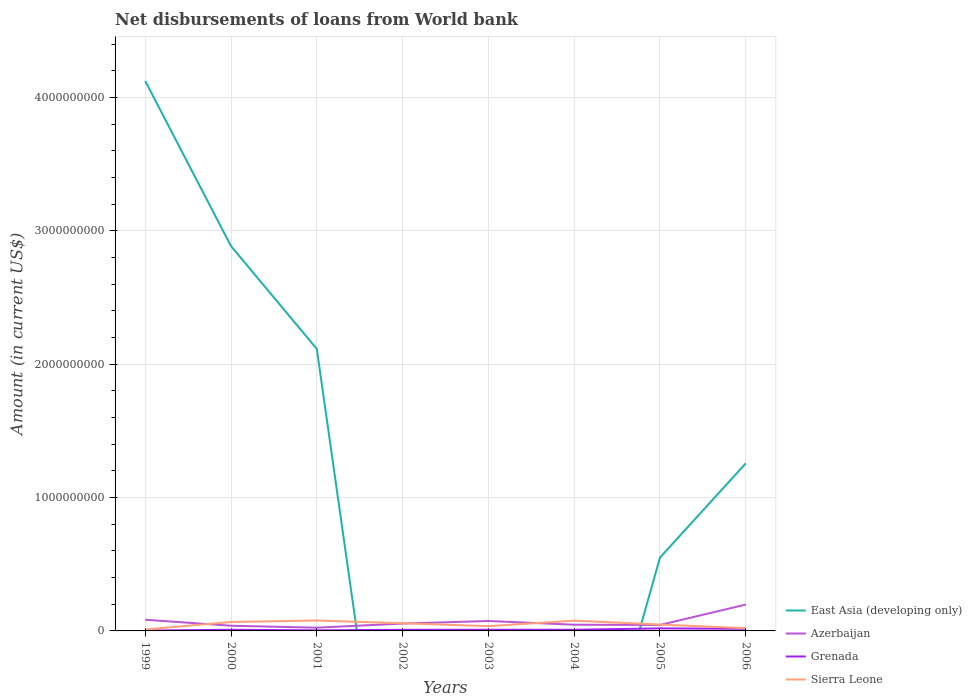How many different coloured lines are there?
Provide a succinct answer. 4. Across all years, what is the maximum amount of loan disbursed from World Bank in Sierra Leone?
Provide a succinct answer. 1.08e+07. What is the total amount of loan disbursed from World Bank in Azerbaijan in the graph?
Provide a succinct answer. 1.05e+07. What is the difference between the highest and the second highest amount of loan disbursed from World Bank in Sierra Leone?
Your response must be concise. 6.74e+07. Is the amount of loan disbursed from World Bank in East Asia (developing only) strictly greater than the amount of loan disbursed from World Bank in Sierra Leone over the years?
Your answer should be very brief. No. Are the values on the major ticks of Y-axis written in scientific E-notation?
Offer a terse response. No. How many legend labels are there?
Your answer should be very brief. 4. How are the legend labels stacked?
Your answer should be compact. Vertical. What is the title of the graph?
Ensure brevity in your answer.  Net disbursements of loans from World bank. What is the label or title of the X-axis?
Your answer should be compact. Years. What is the label or title of the Y-axis?
Offer a very short reply. Amount (in current US$). What is the Amount (in current US$) of East Asia (developing only) in 1999?
Offer a terse response. 4.12e+09. What is the Amount (in current US$) of Azerbaijan in 1999?
Provide a short and direct response. 8.39e+07. What is the Amount (in current US$) in Grenada in 1999?
Offer a terse response. 2.70e+06. What is the Amount (in current US$) in Sierra Leone in 1999?
Ensure brevity in your answer.  1.08e+07. What is the Amount (in current US$) in East Asia (developing only) in 2000?
Provide a short and direct response. 2.89e+09. What is the Amount (in current US$) of Azerbaijan in 2000?
Provide a succinct answer. 3.89e+07. What is the Amount (in current US$) in Grenada in 2000?
Offer a very short reply. 8.52e+06. What is the Amount (in current US$) of Sierra Leone in 2000?
Keep it short and to the point. 6.69e+07. What is the Amount (in current US$) of East Asia (developing only) in 2001?
Make the answer very short. 2.11e+09. What is the Amount (in current US$) in Azerbaijan in 2001?
Offer a very short reply. 2.43e+07. What is the Amount (in current US$) of Grenada in 2001?
Your answer should be compact. 4.25e+06. What is the Amount (in current US$) of Sierra Leone in 2001?
Offer a terse response. 7.82e+07. What is the Amount (in current US$) in Azerbaijan in 2002?
Your answer should be compact. 5.52e+07. What is the Amount (in current US$) in Grenada in 2002?
Offer a very short reply. 8.38e+06. What is the Amount (in current US$) in Sierra Leone in 2002?
Give a very brief answer. 5.74e+07. What is the Amount (in current US$) in Azerbaijan in 2003?
Keep it short and to the point. 7.45e+07. What is the Amount (in current US$) of Grenada in 2003?
Offer a very short reply. 8.82e+06. What is the Amount (in current US$) in Sierra Leone in 2003?
Your answer should be very brief. 3.57e+07. What is the Amount (in current US$) of East Asia (developing only) in 2004?
Give a very brief answer. 0. What is the Amount (in current US$) in Azerbaijan in 2004?
Your response must be concise. 4.63e+07. What is the Amount (in current US$) in Grenada in 2004?
Provide a succinct answer. 8.74e+06. What is the Amount (in current US$) in Sierra Leone in 2004?
Offer a terse response. 7.70e+07. What is the Amount (in current US$) in East Asia (developing only) in 2005?
Your answer should be very brief. 5.50e+08. What is the Amount (in current US$) of Azerbaijan in 2005?
Keep it short and to the point. 4.46e+07. What is the Amount (in current US$) in Grenada in 2005?
Provide a short and direct response. 1.90e+07. What is the Amount (in current US$) in Sierra Leone in 2005?
Ensure brevity in your answer.  4.77e+07. What is the Amount (in current US$) in East Asia (developing only) in 2006?
Your answer should be very brief. 1.26e+09. What is the Amount (in current US$) of Azerbaijan in 2006?
Offer a very short reply. 1.98e+08. What is the Amount (in current US$) of Grenada in 2006?
Ensure brevity in your answer.  1.61e+07. What is the Amount (in current US$) of Sierra Leone in 2006?
Ensure brevity in your answer.  2.05e+07. Across all years, what is the maximum Amount (in current US$) of East Asia (developing only)?
Provide a short and direct response. 4.12e+09. Across all years, what is the maximum Amount (in current US$) of Azerbaijan?
Your answer should be compact. 1.98e+08. Across all years, what is the maximum Amount (in current US$) in Grenada?
Make the answer very short. 1.90e+07. Across all years, what is the maximum Amount (in current US$) of Sierra Leone?
Your answer should be very brief. 7.82e+07. Across all years, what is the minimum Amount (in current US$) in Azerbaijan?
Your answer should be very brief. 2.43e+07. Across all years, what is the minimum Amount (in current US$) of Grenada?
Offer a very short reply. 2.70e+06. Across all years, what is the minimum Amount (in current US$) of Sierra Leone?
Offer a terse response. 1.08e+07. What is the total Amount (in current US$) in East Asia (developing only) in the graph?
Provide a short and direct response. 1.09e+1. What is the total Amount (in current US$) in Azerbaijan in the graph?
Your answer should be very brief. 5.65e+08. What is the total Amount (in current US$) in Grenada in the graph?
Keep it short and to the point. 7.65e+07. What is the total Amount (in current US$) of Sierra Leone in the graph?
Provide a succinct answer. 3.94e+08. What is the difference between the Amount (in current US$) in East Asia (developing only) in 1999 and that in 2000?
Your answer should be very brief. 1.24e+09. What is the difference between the Amount (in current US$) of Azerbaijan in 1999 and that in 2000?
Give a very brief answer. 4.50e+07. What is the difference between the Amount (in current US$) of Grenada in 1999 and that in 2000?
Offer a terse response. -5.82e+06. What is the difference between the Amount (in current US$) of Sierra Leone in 1999 and that in 2000?
Your answer should be very brief. -5.61e+07. What is the difference between the Amount (in current US$) of East Asia (developing only) in 1999 and that in 2001?
Offer a very short reply. 2.01e+09. What is the difference between the Amount (in current US$) in Azerbaijan in 1999 and that in 2001?
Offer a very short reply. 5.96e+07. What is the difference between the Amount (in current US$) of Grenada in 1999 and that in 2001?
Ensure brevity in your answer.  -1.55e+06. What is the difference between the Amount (in current US$) in Sierra Leone in 1999 and that in 2001?
Offer a terse response. -6.74e+07. What is the difference between the Amount (in current US$) in Azerbaijan in 1999 and that in 2002?
Provide a succinct answer. 2.88e+07. What is the difference between the Amount (in current US$) of Grenada in 1999 and that in 2002?
Offer a very short reply. -5.67e+06. What is the difference between the Amount (in current US$) in Sierra Leone in 1999 and that in 2002?
Provide a succinct answer. -4.67e+07. What is the difference between the Amount (in current US$) of Azerbaijan in 1999 and that in 2003?
Offer a very short reply. 9.45e+06. What is the difference between the Amount (in current US$) of Grenada in 1999 and that in 2003?
Offer a very short reply. -6.12e+06. What is the difference between the Amount (in current US$) in Sierra Leone in 1999 and that in 2003?
Provide a short and direct response. -2.50e+07. What is the difference between the Amount (in current US$) of Azerbaijan in 1999 and that in 2004?
Make the answer very short. 3.76e+07. What is the difference between the Amount (in current US$) in Grenada in 1999 and that in 2004?
Offer a very short reply. -6.04e+06. What is the difference between the Amount (in current US$) in Sierra Leone in 1999 and that in 2004?
Ensure brevity in your answer.  -6.63e+07. What is the difference between the Amount (in current US$) of East Asia (developing only) in 1999 and that in 2005?
Ensure brevity in your answer.  3.57e+09. What is the difference between the Amount (in current US$) in Azerbaijan in 1999 and that in 2005?
Offer a terse response. 3.93e+07. What is the difference between the Amount (in current US$) in Grenada in 1999 and that in 2005?
Provide a succinct answer. -1.63e+07. What is the difference between the Amount (in current US$) in Sierra Leone in 1999 and that in 2005?
Provide a short and direct response. -3.70e+07. What is the difference between the Amount (in current US$) in East Asia (developing only) in 1999 and that in 2006?
Your response must be concise. 2.87e+09. What is the difference between the Amount (in current US$) in Azerbaijan in 1999 and that in 2006?
Your response must be concise. -1.14e+08. What is the difference between the Amount (in current US$) of Grenada in 1999 and that in 2006?
Your response must be concise. -1.34e+07. What is the difference between the Amount (in current US$) of Sierra Leone in 1999 and that in 2006?
Offer a terse response. -9.74e+06. What is the difference between the Amount (in current US$) in East Asia (developing only) in 2000 and that in 2001?
Give a very brief answer. 7.71e+08. What is the difference between the Amount (in current US$) in Azerbaijan in 2000 and that in 2001?
Offer a very short reply. 1.46e+07. What is the difference between the Amount (in current US$) of Grenada in 2000 and that in 2001?
Give a very brief answer. 4.27e+06. What is the difference between the Amount (in current US$) in Sierra Leone in 2000 and that in 2001?
Provide a succinct answer. -1.13e+07. What is the difference between the Amount (in current US$) of Azerbaijan in 2000 and that in 2002?
Ensure brevity in your answer.  -1.62e+07. What is the difference between the Amount (in current US$) in Grenada in 2000 and that in 2002?
Give a very brief answer. 1.44e+05. What is the difference between the Amount (in current US$) of Sierra Leone in 2000 and that in 2002?
Provide a short and direct response. 9.44e+06. What is the difference between the Amount (in current US$) of Azerbaijan in 2000 and that in 2003?
Make the answer very short. -3.55e+07. What is the difference between the Amount (in current US$) of Grenada in 2000 and that in 2003?
Your answer should be very brief. -2.98e+05. What is the difference between the Amount (in current US$) in Sierra Leone in 2000 and that in 2003?
Give a very brief answer. 3.12e+07. What is the difference between the Amount (in current US$) in Azerbaijan in 2000 and that in 2004?
Your response must be concise. -7.41e+06. What is the difference between the Amount (in current US$) in Grenada in 2000 and that in 2004?
Give a very brief answer. -2.22e+05. What is the difference between the Amount (in current US$) of Sierra Leone in 2000 and that in 2004?
Keep it short and to the point. -1.02e+07. What is the difference between the Amount (in current US$) in East Asia (developing only) in 2000 and that in 2005?
Provide a short and direct response. 2.34e+09. What is the difference between the Amount (in current US$) of Azerbaijan in 2000 and that in 2005?
Your answer should be compact. -5.71e+06. What is the difference between the Amount (in current US$) in Grenada in 2000 and that in 2005?
Give a very brief answer. -1.05e+07. What is the difference between the Amount (in current US$) in Sierra Leone in 2000 and that in 2005?
Give a very brief answer. 1.91e+07. What is the difference between the Amount (in current US$) of East Asia (developing only) in 2000 and that in 2006?
Keep it short and to the point. 1.63e+09. What is the difference between the Amount (in current US$) of Azerbaijan in 2000 and that in 2006?
Provide a short and direct response. -1.59e+08. What is the difference between the Amount (in current US$) in Grenada in 2000 and that in 2006?
Offer a very short reply. -7.58e+06. What is the difference between the Amount (in current US$) of Sierra Leone in 2000 and that in 2006?
Keep it short and to the point. 4.64e+07. What is the difference between the Amount (in current US$) in Azerbaijan in 2001 and that in 2002?
Make the answer very short. -3.09e+07. What is the difference between the Amount (in current US$) of Grenada in 2001 and that in 2002?
Make the answer very short. -4.12e+06. What is the difference between the Amount (in current US$) in Sierra Leone in 2001 and that in 2002?
Make the answer very short. 2.08e+07. What is the difference between the Amount (in current US$) in Azerbaijan in 2001 and that in 2003?
Make the answer very short. -5.02e+07. What is the difference between the Amount (in current US$) in Grenada in 2001 and that in 2003?
Make the answer very short. -4.57e+06. What is the difference between the Amount (in current US$) in Sierra Leone in 2001 and that in 2003?
Keep it short and to the point. 4.25e+07. What is the difference between the Amount (in current US$) in Azerbaijan in 2001 and that in 2004?
Make the answer very short. -2.20e+07. What is the difference between the Amount (in current US$) of Grenada in 2001 and that in 2004?
Provide a short and direct response. -4.49e+06. What is the difference between the Amount (in current US$) in Sierra Leone in 2001 and that in 2004?
Make the answer very short. 1.15e+06. What is the difference between the Amount (in current US$) of East Asia (developing only) in 2001 and that in 2005?
Your answer should be compact. 1.56e+09. What is the difference between the Amount (in current US$) of Azerbaijan in 2001 and that in 2005?
Offer a terse response. -2.04e+07. What is the difference between the Amount (in current US$) of Grenada in 2001 and that in 2005?
Keep it short and to the point. -1.47e+07. What is the difference between the Amount (in current US$) of Sierra Leone in 2001 and that in 2005?
Provide a succinct answer. 3.05e+07. What is the difference between the Amount (in current US$) of East Asia (developing only) in 2001 and that in 2006?
Your answer should be compact. 8.58e+08. What is the difference between the Amount (in current US$) in Azerbaijan in 2001 and that in 2006?
Keep it short and to the point. -1.73e+08. What is the difference between the Amount (in current US$) of Grenada in 2001 and that in 2006?
Make the answer very short. -1.18e+07. What is the difference between the Amount (in current US$) of Sierra Leone in 2001 and that in 2006?
Ensure brevity in your answer.  5.77e+07. What is the difference between the Amount (in current US$) of Azerbaijan in 2002 and that in 2003?
Make the answer very short. -1.93e+07. What is the difference between the Amount (in current US$) in Grenada in 2002 and that in 2003?
Your answer should be compact. -4.42e+05. What is the difference between the Amount (in current US$) in Sierra Leone in 2002 and that in 2003?
Ensure brevity in your answer.  2.17e+07. What is the difference between the Amount (in current US$) of Azerbaijan in 2002 and that in 2004?
Offer a terse response. 8.82e+06. What is the difference between the Amount (in current US$) in Grenada in 2002 and that in 2004?
Your response must be concise. -3.66e+05. What is the difference between the Amount (in current US$) of Sierra Leone in 2002 and that in 2004?
Your answer should be compact. -1.96e+07. What is the difference between the Amount (in current US$) of Azerbaijan in 2002 and that in 2005?
Ensure brevity in your answer.  1.05e+07. What is the difference between the Amount (in current US$) in Grenada in 2002 and that in 2005?
Keep it short and to the point. -1.06e+07. What is the difference between the Amount (in current US$) of Sierra Leone in 2002 and that in 2005?
Ensure brevity in your answer.  9.70e+06. What is the difference between the Amount (in current US$) in Azerbaijan in 2002 and that in 2006?
Keep it short and to the point. -1.42e+08. What is the difference between the Amount (in current US$) in Grenada in 2002 and that in 2006?
Ensure brevity in your answer.  -7.72e+06. What is the difference between the Amount (in current US$) in Sierra Leone in 2002 and that in 2006?
Provide a short and direct response. 3.69e+07. What is the difference between the Amount (in current US$) in Azerbaijan in 2003 and that in 2004?
Your response must be concise. 2.81e+07. What is the difference between the Amount (in current US$) of Grenada in 2003 and that in 2004?
Provide a short and direct response. 7.60e+04. What is the difference between the Amount (in current US$) in Sierra Leone in 2003 and that in 2004?
Keep it short and to the point. -4.13e+07. What is the difference between the Amount (in current US$) of Azerbaijan in 2003 and that in 2005?
Make the answer very short. 2.98e+07. What is the difference between the Amount (in current US$) in Grenada in 2003 and that in 2005?
Your answer should be compact. -1.02e+07. What is the difference between the Amount (in current US$) of Sierra Leone in 2003 and that in 2005?
Provide a short and direct response. -1.20e+07. What is the difference between the Amount (in current US$) in Azerbaijan in 2003 and that in 2006?
Offer a very short reply. -1.23e+08. What is the difference between the Amount (in current US$) in Grenada in 2003 and that in 2006?
Give a very brief answer. -7.28e+06. What is the difference between the Amount (in current US$) of Sierra Leone in 2003 and that in 2006?
Your response must be concise. 1.52e+07. What is the difference between the Amount (in current US$) in Azerbaijan in 2004 and that in 2005?
Your response must be concise. 1.70e+06. What is the difference between the Amount (in current US$) in Grenada in 2004 and that in 2005?
Make the answer very short. -1.02e+07. What is the difference between the Amount (in current US$) of Sierra Leone in 2004 and that in 2005?
Ensure brevity in your answer.  2.93e+07. What is the difference between the Amount (in current US$) in Azerbaijan in 2004 and that in 2006?
Offer a very short reply. -1.51e+08. What is the difference between the Amount (in current US$) in Grenada in 2004 and that in 2006?
Provide a short and direct response. -7.36e+06. What is the difference between the Amount (in current US$) of Sierra Leone in 2004 and that in 2006?
Your answer should be very brief. 5.65e+07. What is the difference between the Amount (in current US$) of East Asia (developing only) in 2005 and that in 2006?
Your answer should be compact. -7.06e+08. What is the difference between the Amount (in current US$) of Azerbaijan in 2005 and that in 2006?
Ensure brevity in your answer.  -1.53e+08. What is the difference between the Amount (in current US$) of Grenada in 2005 and that in 2006?
Keep it short and to the point. 2.88e+06. What is the difference between the Amount (in current US$) in Sierra Leone in 2005 and that in 2006?
Give a very brief answer. 2.72e+07. What is the difference between the Amount (in current US$) in East Asia (developing only) in 1999 and the Amount (in current US$) in Azerbaijan in 2000?
Offer a very short reply. 4.08e+09. What is the difference between the Amount (in current US$) in East Asia (developing only) in 1999 and the Amount (in current US$) in Grenada in 2000?
Offer a very short reply. 4.11e+09. What is the difference between the Amount (in current US$) in East Asia (developing only) in 1999 and the Amount (in current US$) in Sierra Leone in 2000?
Provide a short and direct response. 4.06e+09. What is the difference between the Amount (in current US$) of Azerbaijan in 1999 and the Amount (in current US$) of Grenada in 2000?
Offer a terse response. 7.54e+07. What is the difference between the Amount (in current US$) in Azerbaijan in 1999 and the Amount (in current US$) in Sierra Leone in 2000?
Offer a terse response. 1.71e+07. What is the difference between the Amount (in current US$) of Grenada in 1999 and the Amount (in current US$) of Sierra Leone in 2000?
Provide a succinct answer. -6.42e+07. What is the difference between the Amount (in current US$) of East Asia (developing only) in 1999 and the Amount (in current US$) of Azerbaijan in 2001?
Give a very brief answer. 4.10e+09. What is the difference between the Amount (in current US$) of East Asia (developing only) in 1999 and the Amount (in current US$) of Grenada in 2001?
Ensure brevity in your answer.  4.12e+09. What is the difference between the Amount (in current US$) of East Asia (developing only) in 1999 and the Amount (in current US$) of Sierra Leone in 2001?
Offer a terse response. 4.05e+09. What is the difference between the Amount (in current US$) in Azerbaijan in 1999 and the Amount (in current US$) in Grenada in 2001?
Offer a terse response. 7.97e+07. What is the difference between the Amount (in current US$) in Azerbaijan in 1999 and the Amount (in current US$) in Sierra Leone in 2001?
Offer a very short reply. 5.74e+06. What is the difference between the Amount (in current US$) of Grenada in 1999 and the Amount (in current US$) of Sierra Leone in 2001?
Your answer should be very brief. -7.55e+07. What is the difference between the Amount (in current US$) in East Asia (developing only) in 1999 and the Amount (in current US$) in Azerbaijan in 2002?
Offer a very short reply. 4.07e+09. What is the difference between the Amount (in current US$) in East Asia (developing only) in 1999 and the Amount (in current US$) in Grenada in 2002?
Keep it short and to the point. 4.11e+09. What is the difference between the Amount (in current US$) in East Asia (developing only) in 1999 and the Amount (in current US$) in Sierra Leone in 2002?
Provide a short and direct response. 4.07e+09. What is the difference between the Amount (in current US$) of Azerbaijan in 1999 and the Amount (in current US$) of Grenada in 2002?
Provide a short and direct response. 7.56e+07. What is the difference between the Amount (in current US$) of Azerbaijan in 1999 and the Amount (in current US$) of Sierra Leone in 2002?
Your response must be concise. 2.65e+07. What is the difference between the Amount (in current US$) of Grenada in 1999 and the Amount (in current US$) of Sierra Leone in 2002?
Ensure brevity in your answer.  -5.47e+07. What is the difference between the Amount (in current US$) in East Asia (developing only) in 1999 and the Amount (in current US$) in Azerbaijan in 2003?
Give a very brief answer. 4.05e+09. What is the difference between the Amount (in current US$) in East Asia (developing only) in 1999 and the Amount (in current US$) in Grenada in 2003?
Offer a terse response. 4.11e+09. What is the difference between the Amount (in current US$) in East Asia (developing only) in 1999 and the Amount (in current US$) in Sierra Leone in 2003?
Ensure brevity in your answer.  4.09e+09. What is the difference between the Amount (in current US$) in Azerbaijan in 1999 and the Amount (in current US$) in Grenada in 2003?
Provide a short and direct response. 7.51e+07. What is the difference between the Amount (in current US$) of Azerbaijan in 1999 and the Amount (in current US$) of Sierra Leone in 2003?
Your answer should be very brief. 4.82e+07. What is the difference between the Amount (in current US$) of Grenada in 1999 and the Amount (in current US$) of Sierra Leone in 2003?
Give a very brief answer. -3.30e+07. What is the difference between the Amount (in current US$) of East Asia (developing only) in 1999 and the Amount (in current US$) of Azerbaijan in 2004?
Offer a terse response. 4.08e+09. What is the difference between the Amount (in current US$) of East Asia (developing only) in 1999 and the Amount (in current US$) of Grenada in 2004?
Give a very brief answer. 4.11e+09. What is the difference between the Amount (in current US$) in East Asia (developing only) in 1999 and the Amount (in current US$) in Sierra Leone in 2004?
Ensure brevity in your answer.  4.05e+09. What is the difference between the Amount (in current US$) of Azerbaijan in 1999 and the Amount (in current US$) of Grenada in 2004?
Your response must be concise. 7.52e+07. What is the difference between the Amount (in current US$) in Azerbaijan in 1999 and the Amount (in current US$) in Sierra Leone in 2004?
Keep it short and to the point. 6.89e+06. What is the difference between the Amount (in current US$) in Grenada in 1999 and the Amount (in current US$) in Sierra Leone in 2004?
Ensure brevity in your answer.  -7.43e+07. What is the difference between the Amount (in current US$) of East Asia (developing only) in 1999 and the Amount (in current US$) of Azerbaijan in 2005?
Offer a terse response. 4.08e+09. What is the difference between the Amount (in current US$) in East Asia (developing only) in 1999 and the Amount (in current US$) in Grenada in 2005?
Keep it short and to the point. 4.10e+09. What is the difference between the Amount (in current US$) in East Asia (developing only) in 1999 and the Amount (in current US$) in Sierra Leone in 2005?
Make the answer very short. 4.08e+09. What is the difference between the Amount (in current US$) of Azerbaijan in 1999 and the Amount (in current US$) of Grenada in 2005?
Keep it short and to the point. 6.50e+07. What is the difference between the Amount (in current US$) in Azerbaijan in 1999 and the Amount (in current US$) in Sierra Leone in 2005?
Provide a succinct answer. 3.62e+07. What is the difference between the Amount (in current US$) of Grenada in 1999 and the Amount (in current US$) of Sierra Leone in 2005?
Your answer should be very brief. -4.50e+07. What is the difference between the Amount (in current US$) in East Asia (developing only) in 1999 and the Amount (in current US$) in Azerbaijan in 2006?
Keep it short and to the point. 3.93e+09. What is the difference between the Amount (in current US$) of East Asia (developing only) in 1999 and the Amount (in current US$) of Grenada in 2006?
Offer a very short reply. 4.11e+09. What is the difference between the Amount (in current US$) of East Asia (developing only) in 1999 and the Amount (in current US$) of Sierra Leone in 2006?
Your answer should be compact. 4.10e+09. What is the difference between the Amount (in current US$) of Azerbaijan in 1999 and the Amount (in current US$) of Grenada in 2006?
Offer a terse response. 6.78e+07. What is the difference between the Amount (in current US$) in Azerbaijan in 1999 and the Amount (in current US$) in Sierra Leone in 2006?
Keep it short and to the point. 6.34e+07. What is the difference between the Amount (in current US$) in Grenada in 1999 and the Amount (in current US$) in Sierra Leone in 2006?
Give a very brief answer. -1.78e+07. What is the difference between the Amount (in current US$) in East Asia (developing only) in 2000 and the Amount (in current US$) in Azerbaijan in 2001?
Give a very brief answer. 2.86e+09. What is the difference between the Amount (in current US$) of East Asia (developing only) in 2000 and the Amount (in current US$) of Grenada in 2001?
Give a very brief answer. 2.88e+09. What is the difference between the Amount (in current US$) of East Asia (developing only) in 2000 and the Amount (in current US$) of Sierra Leone in 2001?
Your answer should be very brief. 2.81e+09. What is the difference between the Amount (in current US$) of Azerbaijan in 2000 and the Amount (in current US$) of Grenada in 2001?
Make the answer very short. 3.47e+07. What is the difference between the Amount (in current US$) in Azerbaijan in 2000 and the Amount (in current US$) in Sierra Leone in 2001?
Your answer should be very brief. -3.92e+07. What is the difference between the Amount (in current US$) in Grenada in 2000 and the Amount (in current US$) in Sierra Leone in 2001?
Your answer should be compact. -6.97e+07. What is the difference between the Amount (in current US$) in East Asia (developing only) in 2000 and the Amount (in current US$) in Azerbaijan in 2002?
Your response must be concise. 2.83e+09. What is the difference between the Amount (in current US$) in East Asia (developing only) in 2000 and the Amount (in current US$) in Grenada in 2002?
Your response must be concise. 2.88e+09. What is the difference between the Amount (in current US$) of East Asia (developing only) in 2000 and the Amount (in current US$) of Sierra Leone in 2002?
Your answer should be compact. 2.83e+09. What is the difference between the Amount (in current US$) in Azerbaijan in 2000 and the Amount (in current US$) in Grenada in 2002?
Keep it short and to the point. 3.06e+07. What is the difference between the Amount (in current US$) of Azerbaijan in 2000 and the Amount (in current US$) of Sierra Leone in 2002?
Provide a succinct answer. -1.85e+07. What is the difference between the Amount (in current US$) of Grenada in 2000 and the Amount (in current US$) of Sierra Leone in 2002?
Ensure brevity in your answer.  -4.89e+07. What is the difference between the Amount (in current US$) of East Asia (developing only) in 2000 and the Amount (in current US$) of Azerbaijan in 2003?
Provide a succinct answer. 2.81e+09. What is the difference between the Amount (in current US$) of East Asia (developing only) in 2000 and the Amount (in current US$) of Grenada in 2003?
Offer a terse response. 2.88e+09. What is the difference between the Amount (in current US$) of East Asia (developing only) in 2000 and the Amount (in current US$) of Sierra Leone in 2003?
Offer a very short reply. 2.85e+09. What is the difference between the Amount (in current US$) of Azerbaijan in 2000 and the Amount (in current US$) of Grenada in 2003?
Your answer should be very brief. 3.01e+07. What is the difference between the Amount (in current US$) in Azerbaijan in 2000 and the Amount (in current US$) in Sierra Leone in 2003?
Keep it short and to the point. 3.22e+06. What is the difference between the Amount (in current US$) of Grenada in 2000 and the Amount (in current US$) of Sierra Leone in 2003?
Make the answer very short. -2.72e+07. What is the difference between the Amount (in current US$) in East Asia (developing only) in 2000 and the Amount (in current US$) in Azerbaijan in 2004?
Make the answer very short. 2.84e+09. What is the difference between the Amount (in current US$) in East Asia (developing only) in 2000 and the Amount (in current US$) in Grenada in 2004?
Provide a short and direct response. 2.88e+09. What is the difference between the Amount (in current US$) of East Asia (developing only) in 2000 and the Amount (in current US$) of Sierra Leone in 2004?
Keep it short and to the point. 2.81e+09. What is the difference between the Amount (in current US$) in Azerbaijan in 2000 and the Amount (in current US$) in Grenada in 2004?
Your answer should be very brief. 3.02e+07. What is the difference between the Amount (in current US$) of Azerbaijan in 2000 and the Amount (in current US$) of Sierra Leone in 2004?
Make the answer very short. -3.81e+07. What is the difference between the Amount (in current US$) in Grenada in 2000 and the Amount (in current US$) in Sierra Leone in 2004?
Your answer should be very brief. -6.85e+07. What is the difference between the Amount (in current US$) in East Asia (developing only) in 2000 and the Amount (in current US$) in Azerbaijan in 2005?
Provide a succinct answer. 2.84e+09. What is the difference between the Amount (in current US$) of East Asia (developing only) in 2000 and the Amount (in current US$) of Grenada in 2005?
Your answer should be very brief. 2.87e+09. What is the difference between the Amount (in current US$) of East Asia (developing only) in 2000 and the Amount (in current US$) of Sierra Leone in 2005?
Ensure brevity in your answer.  2.84e+09. What is the difference between the Amount (in current US$) in Azerbaijan in 2000 and the Amount (in current US$) in Grenada in 2005?
Keep it short and to the point. 2.00e+07. What is the difference between the Amount (in current US$) of Azerbaijan in 2000 and the Amount (in current US$) of Sierra Leone in 2005?
Keep it short and to the point. -8.80e+06. What is the difference between the Amount (in current US$) in Grenada in 2000 and the Amount (in current US$) in Sierra Leone in 2005?
Keep it short and to the point. -3.92e+07. What is the difference between the Amount (in current US$) in East Asia (developing only) in 2000 and the Amount (in current US$) in Azerbaijan in 2006?
Your answer should be compact. 2.69e+09. What is the difference between the Amount (in current US$) of East Asia (developing only) in 2000 and the Amount (in current US$) of Grenada in 2006?
Your answer should be very brief. 2.87e+09. What is the difference between the Amount (in current US$) of East Asia (developing only) in 2000 and the Amount (in current US$) of Sierra Leone in 2006?
Your response must be concise. 2.86e+09. What is the difference between the Amount (in current US$) in Azerbaijan in 2000 and the Amount (in current US$) in Grenada in 2006?
Offer a very short reply. 2.28e+07. What is the difference between the Amount (in current US$) in Azerbaijan in 2000 and the Amount (in current US$) in Sierra Leone in 2006?
Keep it short and to the point. 1.84e+07. What is the difference between the Amount (in current US$) in Grenada in 2000 and the Amount (in current US$) in Sierra Leone in 2006?
Make the answer very short. -1.20e+07. What is the difference between the Amount (in current US$) of East Asia (developing only) in 2001 and the Amount (in current US$) of Azerbaijan in 2002?
Ensure brevity in your answer.  2.06e+09. What is the difference between the Amount (in current US$) of East Asia (developing only) in 2001 and the Amount (in current US$) of Grenada in 2002?
Provide a succinct answer. 2.11e+09. What is the difference between the Amount (in current US$) of East Asia (developing only) in 2001 and the Amount (in current US$) of Sierra Leone in 2002?
Give a very brief answer. 2.06e+09. What is the difference between the Amount (in current US$) in Azerbaijan in 2001 and the Amount (in current US$) in Grenada in 2002?
Ensure brevity in your answer.  1.59e+07. What is the difference between the Amount (in current US$) in Azerbaijan in 2001 and the Amount (in current US$) in Sierra Leone in 2002?
Give a very brief answer. -3.31e+07. What is the difference between the Amount (in current US$) of Grenada in 2001 and the Amount (in current US$) of Sierra Leone in 2002?
Provide a short and direct response. -5.32e+07. What is the difference between the Amount (in current US$) of East Asia (developing only) in 2001 and the Amount (in current US$) of Azerbaijan in 2003?
Offer a terse response. 2.04e+09. What is the difference between the Amount (in current US$) in East Asia (developing only) in 2001 and the Amount (in current US$) in Grenada in 2003?
Offer a terse response. 2.11e+09. What is the difference between the Amount (in current US$) of East Asia (developing only) in 2001 and the Amount (in current US$) of Sierra Leone in 2003?
Offer a terse response. 2.08e+09. What is the difference between the Amount (in current US$) of Azerbaijan in 2001 and the Amount (in current US$) of Grenada in 2003?
Offer a very short reply. 1.55e+07. What is the difference between the Amount (in current US$) of Azerbaijan in 2001 and the Amount (in current US$) of Sierra Leone in 2003?
Your response must be concise. -1.14e+07. What is the difference between the Amount (in current US$) of Grenada in 2001 and the Amount (in current US$) of Sierra Leone in 2003?
Provide a short and direct response. -3.15e+07. What is the difference between the Amount (in current US$) of East Asia (developing only) in 2001 and the Amount (in current US$) of Azerbaijan in 2004?
Ensure brevity in your answer.  2.07e+09. What is the difference between the Amount (in current US$) in East Asia (developing only) in 2001 and the Amount (in current US$) in Grenada in 2004?
Your response must be concise. 2.11e+09. What is the difference between the Amount (in current US$) in East Asia (developing only) in 2001 and the Amount (in current US$) in Sierra Leone in 2004?
Keep it short and to the point. 2.04e+09. What is the difference between the Amount (in current US$) of Azerbaijan in 2001 and the Amount (in current US$) of Grenada in 2004?
Ensure brevity in your answer.  1.56e+07. What is the difference between the Amount (in current US$) of Azerbaijan in 2001 and the Amount (in current US$) of Sierra Leone in 2004?
Ensure brevity in your answer.  -5.27e+07. What is the difference between the Amount (in current US$) of Grenada in 2001 and the Amount (in current US$) of Sierra Leone in 2004?
Keep it short and to the point. -7.28e+07. What is the difference between the Amount (in current US$) of East Asia (developing only) in 2001 and the Amount (in current US$) of Azerbaijan in 2005?
Ensure brevity in your answer.  2.07e+09. What is the difference between the Amount (in current US$) in East Asia (developing only) in 2001 and the Amount (in current US$) in Grenada in 2005?
Provide a succinct answer. 2.10e+09. What is the difference between the Amount (in current US$) of East Asia (developing only) in 2001 and the Amount (in current US$) of Sierra Leone in 2005?
Offer a terse response. 2.07e+09. What is the difference between the Amount (in current US$) in Azerbaijan in 2001 and the Amount (in current US$) in Grenada in 2005?
Your response must be concise. 5.32e+06. What is the difference between the Amount (in current US$) in Azerbaijan in 2001 and the Amount (in current US$) in Sierra Leone in 2005?
Your answer should be compact. -2.34e+07. What is the difference between the Amount (in current US$) in Grenada in 2001 and the Amount (in current US$) in Sierra Leone in 2005?
Make the answer very short. -4.35e+07. What is the difference between the Amount (in current US$) in East Asia (developing only) in 2001 and the Amount (in current US$) in Azerbaijan in 2006?
Make the answer very short. 1.92e+09. What is the difference between the Amount (in current US$) in East Asia (developing only) in 2001 and the Amount (in current US$) in Grenada in 2006?
Ensure brevity in your answer.  2.10e+09. What is the difference between the Amount (in current US$) in East Asia (developing only) in 2001 and the Amount (in current US$) in Sierra Leone in 2006?
Keep it short and to the point. 2.09e+09. What is the difference between the Amount (in current US$) of Azerbaijan in 2001 and the Amount (in current US$) of Grenada in 2006?
Your response must be concise. 8.20e+06. What is the difference between the Amount (in current US$) of Azerbaijan in 2001 and the Amount (in current US$) of Sierra Leone in 2006?
Give a very brief answer. 3.79e+06. What is the difference between the Amount (in current US$) of Grenada in 2001 and the Amount (in current US$) of Sierra Leone in 2006?
Give a very brief answer. -1.63e+07. What is the difference between the Amount (in current US$) in Azerbaijan in 2002 and the Amount (in current US$) in Grenada in 2003?
Provide a short and direct response. 4.63e+07. What is the difference between the Amount (in current US$) of Azerbaijan in 2002 and the Amount (in current US$) of Sierra Leone in 2003?
Keep it short and to the point. 1.94e+07. What is the difference between the Amount (in current US$) in Grenada in 2002 and the Amount (in current US$) in Sierra Leone in 2003?
Ensure brevity in your answer.  -2.73e+07. What is the difference between the Amount (in current US$) of Azerbaijan in 2002 and the Amount (in current US$) of Grenada in 2004?
Provide a succinct answer. 4.64e+07. What is the difference between the Amount (in current US$) of Azerbaijan in 2002 and the Amount (in current US$) of Sierra Leone in 2004?
Ensure brevity in your answer.  -2.19e+07. What is the difference between the Amount (in current US$) of Grenada in 2002 and the Amount (in current US$) of Sierra Leone in 2004?
Your answer should be compact. -6.87e+07. What is the difference between the Amount (in current US$) of Azerbaijan in 2002 and the Amount (in current US$) of Grenada in 2005?
Keep it short and to the point. 3.62e+07. What is the difference between the Amount (in current US$) in Azerbaijan in 2002 and the Amount (in current US$) in Sierra Leone in 2005?
Your answer should be compact. 7.43e+06. What is the difference between the Amount (in current US$) in Grenada in 2002 and the Amount (in current US$) in Sierra Leone in 2005?
Your response must be concise. -3.94e+07. What is the difference between the Amount (in current US$) in Azerbaijan in 2002 and the Amount (in current US$) in Grenada in 2006?
Provide a succinct answer. 3.91e+07. What is the difference between the Amount (in current US$) in Azerbaijan in 2002 and the Amount (in current US$) in Sierra Leone in 2006?
Your response must be concise. 3.47e+07. What is the difference between the Amount (in current US$) of Grenada in 2002 and the Amount (in current US$) of Sierra Leone in 2006?
Offer a very short reply. -1.21e+07. What is the difference between the Amount (in current US$) in Azerbaijan in 2003 and the Amount (in current US$) in Grenada in 2004?
Provide a short and direct response. 6.57e+07. What is the difference between the Amount (in current US$) in Azerbaijan in 2003 and the Amount (in current US$) in Sierra Leone in 2004?
Your answer should be very brief. -2.56e+06. What is the difference between the Amount (in current US$) in Grenada in 2003 and the Amount (in current US$) in Sierra Leone in 2004?
Provide a succinct answer. -6.82e+07. What is the difference between the Amount (in current US$) of Azerbaijan in 2003 and the Amount (in current US$) of Grenada in 2005?
Offer a very short reply. 5.55e+07. What is the difference between the Amount (in current US$) in Azerbaijan in 2003 and the Amount (in current US$) in Sierra Leone in 2005?
Your answer should be very brief. 2.67e+07. What is the difference between the Amount (in current US$) of Grenada in 2003 and the Amount (in current US$) of Sierra Leone in 2005?
Provide a succinct answer. -3.89e+07. What is the difference between the Amount (in current US$) in Azerbaijan in 2003 and the Amount (in current US$) in Grenada in 2006?
Give a very brief answer. 5.84e+07. What is the difference between the Amount (in current US$) in Azerbaijan in 2003 and the Amount (in current US$) in Sierra Leone in 2006?
Ensure brevity in your answer.  5.40e+07. What is the difference between the Amount (in current US$) of Grenada in 2003 and the Amount (in current US$) of Sierra Leone in 2006?
Give a very brief answer. -1.17e+07. What is the difference between the Amount (in current US$) in Azerbaijan in 2004 and the Amount (in current US$) in Grenada in 2005?
Ensure brevity in your answer.  2.74e+07. What is the difference between the Amount (in current US$) in Azerbaijan in 2004 and the Amount (in current US$) in Sierra Leone in 2005?
Your response must be concise. -1.39e+06. What is the difference between the Amount (in current US$) in Grenada in 2004 and the Amount (in current US$) in Sierra Leone in 2005?
Your answer should be compact. -3.90e+07. What is the difference between the Amount (in current US$) of Azerbaijan in 2004 and the Amount (in current US$) of Grenada in 2006?
Give a very brief answer. 3.02e+07. What is the difference between the Amount (in current US$) of Azerbaijan in 2004 and the Amount (in current US$) of Sierra Leone in 2006?
Make the answer very short. 2.58e+07. What is the difference between the Amount (in current US$) in Grenada in 2004 and the Amount (in current US$) in Sierra Leone in 2006?
Your response must be concise. -1.18e+07. What is the difference between the Amount (in current US$) in East Asia (developing only) in 2005 and the Amount (in current US$) in Azerbaijan in 2006?
Make the answer very short. 3.53e+08. What is the difference between the Amount (in current US$) of East Asia (developing only) in 2005 and the Amount (in current US$) of Grenada in 2006?
Your answer should be very brief. 5.34e+08. What is the difference between the Amount (in current US$) of East Asia (developing only) in 2005 and the Amount (in current US$) of Sierra Leone in 2006?
Make the answer very short. 5.30e+08. What is the difference between the Amount (in current US$) of Azerbaijan in 2005 and the Amount (in current US$) of Grenada in 2006?
Provide a short and direct response. 2.86e+07. What is the difference between the Amount (in current US$) in Azerbaijan in 2005 and the Amount (in current US$) in Sierra Leone in 2006?
Provide a succinct answer. 2.41e+07. What is the difference between the Amount (in current US$) of Grenada in 2005 and the Amount (in current US$) of Sierra Leone in 2006?
Your response must be concise. -1.54e+06. What is the average Amount (in current US$) of East Asia (developing only) per year?
Provide a short and direct response. 1.37e+09. What is the average Amount (in current US$) in Azerbaijan per year?
Your answer should be very brief. 7.07e+07. What is the average Amount (in current US$) of Grenada per year?
Offer a terse response. 9.56e+06. What is the average Amount (in current US$) of Sierra Leone per year?
Keep it short and to the point. 4.93e+07. In the year 1999, what is the difference between the Amount (in current US$) of East Asia (developing only) and Amount (in current US$) of Azerbaijan?
Give a very brief answer. 4.04e+09. In the year 1999, what is the difference between the Amount (in current US$) in East Asia (developing only) and Amount (in current US$) in Grenada?
Give a very brief answer. 4.12e+09. In the year 1999, what is the difference between the Amount (in current US$) in East Asia (developing only) and Amount (in current US$) in Sierra Leone?
Provide a short and direct response. 4.11e+09. In the year 1999, what is the difference between the Amount (in current US$) of Azerbaijan and Amount (in current US$) of Grenada?
Your answer should be compact. 8.12e+07. In the year 1999, what is the difference between the Amount (in current US$) in Azerbaijan and Amount (in current US$) in Sierra Leone?
Offer a terse response. 7.32e+07. In the year 1999, what is the difference between the Amount (in current US$) in Grenada and Amount (in current US$) in Sierra Leone?
Make the answer very short. -8.06e+06. In the year 2000, what is the difference between the Amount (in current US$) in East Asia (developing only) and Amount (in current US$) in Azerbaijan?
Offer a terse response. 2.85e+09. In the year 2000, what is the difference between the Amount (in current US$) of East Asia (developing only) and Amount (in current US$) of Grenada?
Provide a short and direct response. 2.88e+09. In the year 2000, what is the difference between the Amount (in current US$) in East Asia (developing only) and Amount (in current US$) in Sierra Leone?
Keep it short and to the point. 2.82e+09. In the year 2000, what is the difference between the Amount (in current US$) of Azerbaijan and Amount (in current US$) of Grenada?
Your answer should be compact. 3.04e+07. In the year 2000, what is the difference between the Amount (in current US$) in Azerbaijan and Amount (in current US$) in Sierra Leone?
Your answer should be compact. -2.79e+07. In the year 2000, what is the difference between the Amount (in current US$) of Grenada and Amount (in current US$) of Sierra Leone?
Provide a succinct answer. -5.84e+07. In the year 2001, what is the difference between the Amount (in current US$) of East Asia (developing only) and Amount (in current US$) of Azerbaijan?
Give a very brief answer. 2.09e+09. In the year 2001, what is the difference between the Amount (in current US$) of East Asia (developing only) and Amount (in current US$) of Grenada?
Your answer should be very brief. 2.11e+09. In the year 2001, what is the difference between the Amount (in current US$) in East Asia (developing only) and Amount (in current US$) in Sierra Leone?
Offer a very short reply. 2.04e+09. In the year 2001, what is the difference between the Amount (in current US$) in Azerbaijan and Amount (in current US$) in Grenada?
Your response must be concise. 2.00e+07. In the year 2001, what is the difference between the Amount (in current US$) of Azerbaijan and Amount (in current US$) of Sierra Leone?
Your answer should be very brief. -5.39e+07. In the year 2001, what is the difference between the Amount (in current US$) of Grenada and Amount (in current US$) of Sierra Leone?
Make the answer very short. -7.39e+07. In the year 2002, what is the difference between the Amount (in current US$) in Azerbaijan and Amount (in current US$) in Grenada?
Give a very brief answer. 4.68e+07. In the year 2002, what is the difference between the Amount (in current US$) of Azerbaijan and Amount (in current US$) of Sierra Leone?
Provide a short and direct response. -2.27e+06. In the year 2002, what is the difference between the Amount (in current US$) of Grenada and Amount (in current US$) of Sierra Leone?
Make the answer very short. -4.91e+07. In the year 2003, what is the difference between the Amount (in current US$) in Azerbaijan and Amount (in current US$) in Grenada?
Ensure brevity in your answer.  6.57e+07. In the year 2003, what is the difference between the Amount (in current US$) of Azerbaijan and Amount (in current US$) of Sierra Leone?
Your response must be concise. 3.88e+07. In the year 2003, what is the difference between the Amount (in current US$) of Grenada and Amount (in current US$) of Sierra Leone?
Your answer should be compact. -2.69e+07. In the year 2004, what is the difference between the Amount (in current US$) of Azerbaijan and Amount (in current US$) of Grenada?
Give a very brief answer. 3.76e+07. In the year 2004, what is the difference between the Amount (in current US$) of Azerbaijan and Amount (in current US$) of Sierra Leone?
Make the answer very short. -3.07e+07. In the year 2004, what is the difference between the Amount (in current US$) in Grenada and Amount (in current US$) in Sierra Leone?
Provide a succinct answer. -6.83e+07. In the year 2005, what is the difference between the Amount (in current US$) in East Asia (developing only) and Amount (in current US$) in Azerbaijan?
Keep it short and to the point. 5.06e+08. In the year 2005, what is the difference between the Amount (in current US$) of East Asia (developing only) and Amount (in current US$) of Grenada?
Provide a succinct answer. 5.31e+08. In the year 2005, what is the difference between the Amount (in current US$) in East Asia (developing only) and Amount (in current US$) in Sierra Leone?
Give a very brief answer. 5.02e+08. In the year 2005, what is the difference between the Amount (in current US$) of Azerbaijan and Amount (in current US$) of Grenada?
Your answer should be very brief. 2.57e+07. In the year 2005, what is the difference between the Amount (in current US$) of Azerbaijan and Amount (in current US$) of Sierra Leone?
Your response must be concise. -3.08e+06. In the year 2005, what is the difference between the Amount (in current US$) in Grenada and Amount (in current US$) in Sierra Leone?
Provide a succinct answer. -2.88e+07. In the year 2006, what is the difference between the Amount (in current US$) of East Asia (developing only) and Amount (in current US$) of Azerbaijan?
Your response must be concise. 1.06e+09. In the year 2006, what is the difference between the Amount (in current US$) of East Asia (developing only) and Amount (in current US$) of Grenada?
Provide a succinct answer. 1.24e+09. In the year 2006, what is the difference between the Amount (in current US$) of East Asia (developing only) and Amount (in current US$) of Sierra Leone?
Ensure brevity in your answer.  1.24e+09. In the year 2006, what is the difference between the Amount (in current US$) in Azerbaijan and Amount (in current US$) in Grenada?
Provide a succinct answer. 1.81e+08. In the year 2006, what is the difference between the Amount (in current US$) in Azerbaijan and Amount (in current US$) in Sierra Leone?
Your answer should be very brief. 1.77e+08. In the year 2006, what is the difference between the Amount (in current US$) in Grenada and Amount (in current US$) in Sierra Leone?
Provide a short and direct response. -4.41e+06. What is the ratio of the Amount (in current US$) in East Asia (developing only) in 1999 to that in 2000?
Provide a short and direct response. 1.43. What is the ratio of the Amount (in current US$) in Azerbaijan in 1999 to that in 2000?
Offer a terse response. 2.16. What is the ratio of the Amount (in current US$) in Grenada in 1999 to that in 2000?
Your answer should be very brief. 0.32. What is the ratio of the Amount (in current US$) of Sierra Leone in 1999 to that in 2000?
Ensure brevity in your answer.  0.16. What is the ratio of the Amount (in current US$) in East Asia (developing only) in 1999 to that in 2001?
Provide a succinct answer. 1.95. What is the ratio of the Amount (in current US$) in Azerbaijan in 1999 to that in 2001?
Offer a very short reply. 3.45. What is the ratio of the Amount (in current US$) of Grenada in 1999 to that in 2001?
Make the answer very short. 0.64. What is the ratio of the Amount (in current US$) in Sierra Leone in 1999 to that in 2001?
Ensure brevity in your answer.  0.14. What is the ratio of the Amount (in current US$) of Azerbaijan in 1999 to that in 2002?
Offer a terse response. 1.52. What is the ratio of the Amount (in current US$) in Grenada in 1999 to that in 2002?
Offer a terse response. 0.32. What is the ratio of the Amount (in current US$) of Sierra Leone in 1999 to that in 2002?
Your answer should be very brief. 0.19. What is the ratio of the Amount (in current US$) in Azerbaijan in 1999 to that in 2003?
Ensure brevity in your answer.  1.13. What is the ratio of the Amount (in current US$) of Grenada in 1999 to that in 2003?
Provide a short and direct response. 0.31. What is the ratio of the Amount (in current US$) of Sierra Leone in 1999 to that in 2003?
Make the answer very short. 0.3. What is the ratio of the Amount (in current US$) of Azerbaijan in 1999 to that in 2004?
Offer a very short reply. 1.81. What is the ratio of the Amount (in current US$) of Grenada in 1999 to that in 2004?
Provide a short and direct response. 0.31. What is the ratio of the Amount (in current US$) in Sierra Leone in 1999 to that in 2004?
Ensure brevity in your answer.  0.14. What is the ratio of the Amount (in current US$) in East Asia (developing only) in 1999 to that in 2005?
Your answer should be very brief. 7.49. What is the ratio of the Amount (in current US$) of Azerbaijan in 1999 to that in 2005?
Give a very brief answer. 1.88. What is the ratio of the Amount (in current US$) in Grenada in 1999 to that in 2005?
Your answer should be very brief. 0.14. What is the ratio of the Amount (in current US$) of Sierra Leone in 1999 to that in 2005?
Ensure brevity in your answer.  0.23. What is the ratio of the Amount (in current US$) of East Asia (developing only) in 1999 to that in 2006?
Your response must be concise. 3.28. What is the ratio of the Amount (in current US$) of Azerbaijan in 1999 to that in 2006?
Ensure brevity in your answer.  0.42. What is the ratio of the Amount (in current US$) of Grenada in 1999 to that in 2006?
Offer a terse response. 0.17. What is the ratio of the Amount (in current US$) of Sierra Leone in 1999 to that in 2006?
Your answer should be compact. 0.52. What is the ratio of the Amount (in current US$) of East Asia (developing only) in 2000 to that in 2001?
Your response must be concise. 1.36. What is the ratio of the Amount (in current US$) in Azerbaijan in 2000 to that in 2001?
Your answer should be compact. 1.6. What is the ratio of the Amount (in current US$) of Grenada in 2000 to that in 2001?
Ensure brevity in your answer.  2. What is the ratio of the Amount (in current US$) in Sierra Leone in 2000 to that in 2001?
Provide a short and direct response. 0.86. What is the ratio of the Amount (in current US$) in Azerbaijan in 2000 to that in 2002?
Keep it short and to the point. 0.71. What is the ratio of the Amount (in current US$) of Grenada in 2000 to that in 2002?
Your answer should be compact. 1.02. What is the ratio of the Amount (in current US$) of Sierra Leone in 2000 to that in 2002?
Offer a very short reply. 1.16. What is the ratio of the Amount (in current US$) of Azerbaijan in 2000 to that in 2003?
Ensure brevity in your answer.  0.52. What is the ratio of the Amount (in current US$) in Grenada in 2000 to that in 2003?
Your response must be concise. 0.97. What is the ratio of the Amount (in current US$) in Sierra Leone in 2000 to that in 2003?
Offer a very short reply. 1.87. What is the ratio of the Amount (in current US$) of Azerbaijan in 2000 to that in 2004?
Your answer should be compact. 0.84. What is the ratio of the Amount (in current US$) of Grenada in 2000 to that in 2004?
Ensure brevity in your answer.  0.97. What is the ratio of the Amount (in current US$) of Sierra Leone in 2000 to that in 2004?
Provide a succinct answer. 0.87. What is the ratio of the Amount (in current US$) of East Asia (developing only) in 2000 to that in 2005?
Keep it short and to the point. 5.24. What is the ratio of the Amount (in current US$) of Azerbaijan in 2000 to that in 2005?
Offer a very short reply. 0.87. What is the ratio of the Amount (in current US$) in Grenada in 2000 to that in 2005?
Give a very brief answer. 0.45. What is the ratio of the Amount (in current US$) in Sierra Leone in 2000 to that in 2005?
Your response must be concise. 1.4. What is the ratio of the Amount (in current US$) of East Asia (developing only) in 2000 to that in 2006?
Make the answer very short. 2.3. What is the ratio of the Amount (in current US$) in Azerbaijan in 2000 to that in 2006?
Offer a very short reply. 0.2. What is the ratio of the Amount (in current US$) in Grenada in 2000 to that in 2006?
Provide a succinct answer. 0.53. What is the ratio of the Amount (in current US$) in Sierra Leone in 2000 to that in 2006?
Your answer should be compact. 3.26. What is the ratio of the Amount (in current US$) in Azerbaijan in 2001 to that in 2002?
Keep it short and to the point. 0.44. What is the ratio of the Amount (in current US$) of Grenada in 2001 to that in 2002?
Make the answer very short. 0.51. What is the ratio of the Amount (in current US$) of Sierra Leone in 2001 to that in 2002?
Offer a terse response. 1.36. What is the ratio of the Amount (in current US$) of Azerbaijan in 2001 to that in 2003?
Give a very brief answer. 0.33. What is the ratio of the Amount (in current US$) in Grenada in 2001 to that in 2003?
Give a very brief answer. 0.48. What is the ratio of the Amount (in current US$) in Sierra Leone in 2001 to that in 2003?
Provide a succinct answer. 2.19. What is the ratio of the Amount (in current US$) in Azerbaijan in 2001 to that in 2004?
Your answer should be very brief. 0.52. What is the ratio of the Amount (in current US$) of Grenada in 2001 to that in 2004?
Your answer should be very brief. 0.49. What is the ratio of the Amount (in current US$) of Sierra Leone in 2001 to that in 2004?
Keep it short and to the point. 1.01. What is the ratio of the Amount (in current US$) of East Asia (developing only) in 2001 to that in 2005?
Provide a short and direct response. 3.84. What is the ratio of the Amount (in current US$) of Azerbaijan in 2001 to that in 2005?
Offer a very short reply. 0.54. What is the ratio of the Amount (in current US$) in Grenada in 2001 to that in 2005?
Make the answer very short. 0.22. What is the ratio of the Amount (in current US$) of Sierra Leone in 2001 to that in 2005?
Provide a short and direct response. 1.64. What is the ratio of the Amount (in current US$) in East Asia (developing only) in 2001 to that in 2006?
Keep it short and to the point. 1.68. What is the ratio of the Amount (in current US$) in Azerbaijan in 2001 to that in 2006?
Make the answer very short. 0.12. What is the ratio of the Amount (in current US$) in Grenada in 2001 to that in 2006?
Offer a very short reply. 0.26. What is the ratio of the Amount (in current US$) of Sierra Leone in 2001 to that in 2006?
Keep it short and to the point. 3.81. What is the ratio of the Amount (in current US$) in Azerbaijan in 2002 to that in 2003?
Your answer should be very brief. 0.74. What is the ratio of the Amount (in current US$) of Grenada in 2002 to that in 2003?
Ensure brevity in your answer.  0.95. What is the ratio of the Amount (in current US$) in Sierra Leone in 2002 to that in 2003?
Your answer should be compact. 1.61. What is the ratio of the Amount (in current US$) of Azerbaijan in 2002 to that in 2004?
Make the answer very short. 1.19. What is the ratio of the Amount (in current US$) in Grenada in 2002 to that in 2004?
Your response must be concise. 0.96. What is the ratio of the Amount (in current US$) of Sierra Leone in 2002 to that in 2004?
Keep it short and to the point. 0.75. What is the ratio of the Amount (in current US$) in Azerbaijan in 2002 to that in 2005?
Provide a short and direct response. 1.24. What is the ratio of the Amount (in current US$) of Grenada in 2002 to that in 2005?
Your answer should be very brief. 0.44. What is the ratio of the Amount (in current US$) of Sierra Leone in 2002 to that in 2005?
Provide a short and direct response. 1.2. What is the ratio of the Amount (in current US$) of Azerbaijan in 2002 to that in 2006?
Keep it short and to the point. 0.28. What is the ratio of the Amount (in current US$) of Grenada in 2002 to that in 2006?
Keep it short and to the point. 0.52. What is the ratio of the Amount (in current US$) in Sierra Leone in 2002 to that in 2006?
Give a very brief answer. 2.8. What is the ratio of the Amount (in current US$) of Azerbaijan in 2003 to that in 2004?
Keep it short and to the point. 1.61. What is the ratio of the Amount (in current US$) in Grenada in 2003 to that in 2004?
Ensure brevity in your answer.  1.01. What is the ratio of the Amount (in current US$) in Sierra Leone in 2003 to that in 2004?
Your answer should be compact. 0.46. What is the ratio of the Amount (in current US$) of Azerbaijan in 2003 to that in 2005?
Give a very brief answer. 1.67. What is the ratio of the Amount (in current US$) of Grenada in 2003 to that in 2005?
Keep it short and to the point. 0.46. What is the ratio of the Amount (in current US$) of Sierra Leone in 2003 to that in 2005?
Your response must be concise. 0.75. What is the ratio of the Amount (in current US$) of Azerbaijan in 2003 to that in 2006?
Your answer should be very brief. 0.38. What is the ratio of the Amount (in current US$) of Grenada in 2003 to that in 2006?
Keep it short and to the point. 0.55. What is the ratio of the Amount (in current US$) of Sierra Leone in 2003 to that in 2006?
Provide a succinct answer. 1.74. What is the ratio of the Amount (in current US$) in Azerbaijan in 2004 to that in 2005?
Offer a very short reply. 1.04. What is the ratio of the Amount (in current US$) of Grenada in 2004 to that in 2005?
Offer a very short reply. 0.46. What is the ratio of the Amount (in current US$) in Sierra Leone in 2004 to that in 2005?
Your response must be concise. 1.61. What is the ratio of the Amount (in current US$) in Azerbaijan in 2004 to that in 2006?
Your response must be concise. 0.23. What is the ratio of the Amount (in current US$) of Grenada in 2004 to that in 2006?
Ensure brevity in your answer.  0.54. What is the ratio of the Amount (in current US$) of Sierra Leone in 2004 to that in 2006?
Offer a very short reply. 3.76. What is the ratio of the Amount (in current US$) in East Asia (developing only) in 2005 to that in 2006?
Ensure brevity in your answer.  0.44. What is the ratio of the Amount (in current US$) of Azerbaijan in 2005 to that in 2006?
Your answer should be compact. 0.23. What is the ratio of the Amount (in current US$) in Grenada in 2005 to that in 2006?
Keep it short and to the point. 1.18. What is the ratio of the Amount (in current US$) of Sierra Leone in 2005 to that in 2006?
Your answer should be compact. 2.33. What is the difference between the highest and the second highest Amount (in current US$) of East Asia (developing only)?
Your answer should be very brief. 1.24e+09. What is the difference between the highest and the second highest Amount (in current US$) in Azerbaijan?
Your answer should be very brief. 1.14e+08. What is the difference between the highest and the second highest Amount (in current US$) of Grenada?
Give a very brief answer. 2.88e+06. What is the difference between the highest and the second highest Amount (in current US$) of Sierra Leone?
Provide a succinct answer. 1.15e+06. What is the difference between the highest and the lowest Amount (in current US$) of East Asia (developing only)?
Provide a short and direct response. 4.12e+09. What is the difference between the highest and the lowest Amount (in current US$) of Azerbaijan?
Ensure brevity in your answer.  1.73e+08. What is the difference between the highest and the lowest Amount (in current US$) of Grenada?
Your answer should be compact. 1.63e+07. What is the difference between the highest and the lowest Amount (in current US$) in Sierra Leone?
Your answer should be compact. 6.74e+07. 